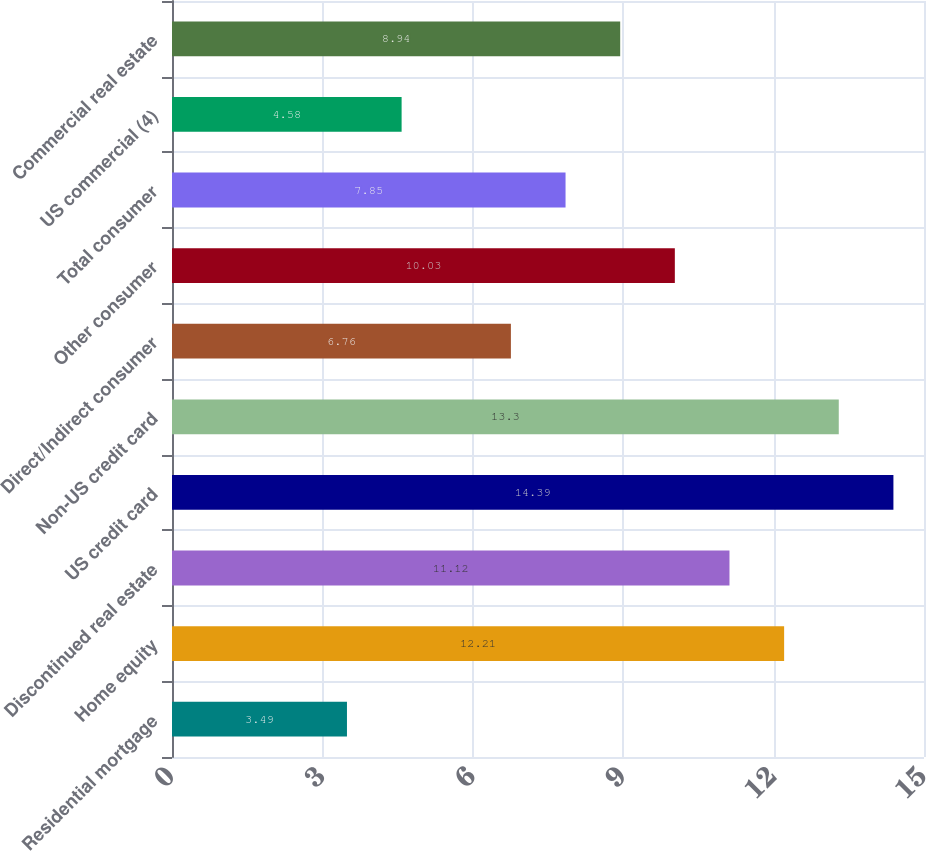Convert chart. <chart><loc_0><loc_0><loc_500><loc_500><bar_chart><fcel>Residential mortgage<fcel>Home equity<fcel>Discontinued real estate<fcel>US credit card<fcel>Non-US credit card<fcel>Direct/Indirect consumer<fcel>Other consumer<fcel>Total consumer<fcel>US commercial (4)<fcel>Commercial real estate<nl><fcel>3.49<fcel>12.21<fcel>11.12<fcel>14.39<fcel>13.3<fcel>6.76<fcel>10.03<fcel>7.85<fcel>4.58<fcel>8.94<nl></chart> 